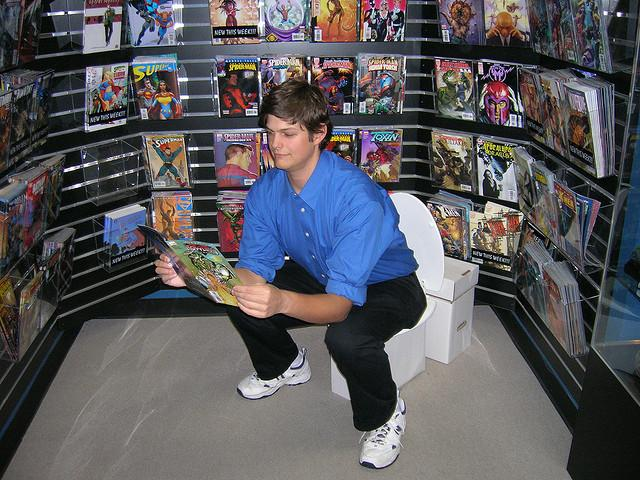What type of store is this? Please explain your reasoning. comic. The guy is reading one and there are many on the shelves around him. 